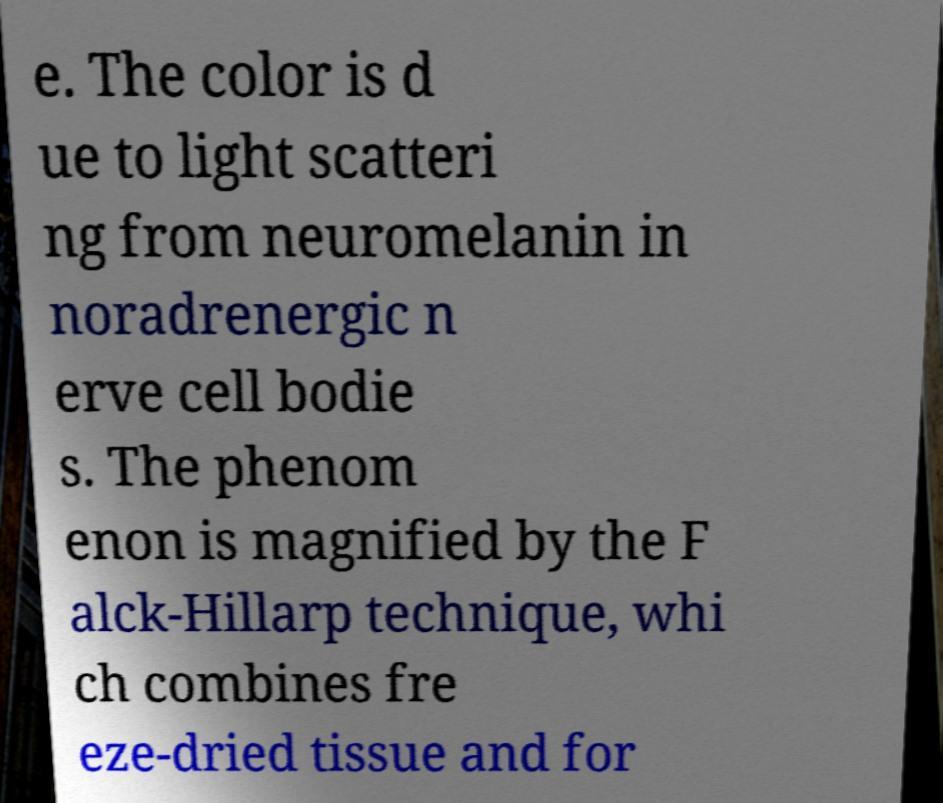Could you extract and type out the text from this image? e. The color is d ue to light scatteri ng from neuromelanin in noradrenergic n erve cell bodie s. The phenom enon is magnified by the F alck-Hillarp technique, whi ch combines fre eze-dried tissue and for 